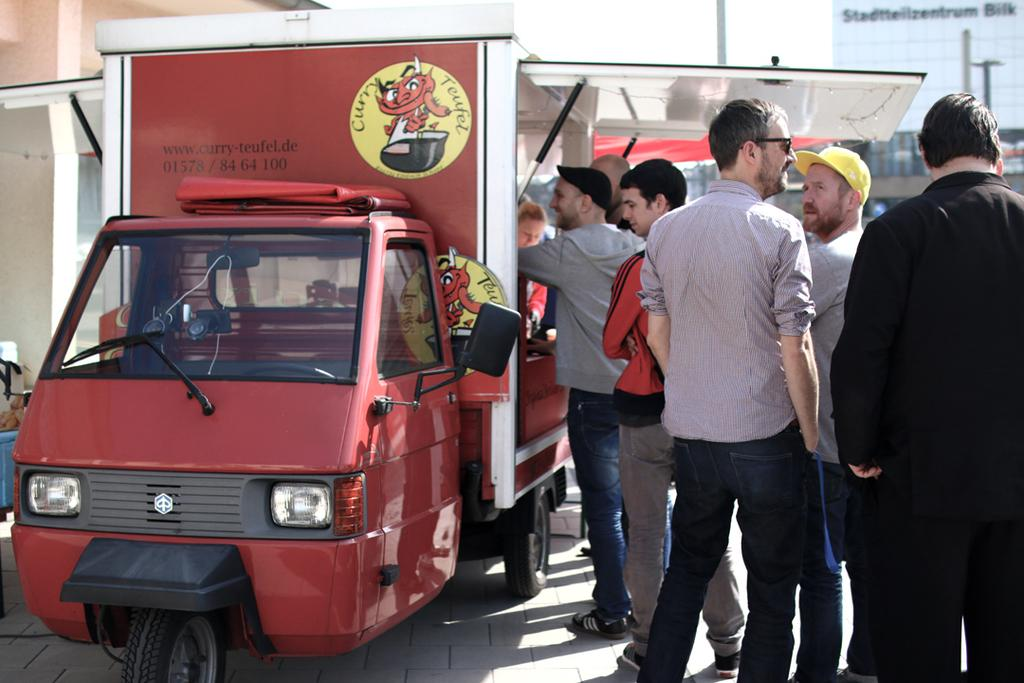What type of vehicle is in the image? There is an auto in the image. What color is the auto? The auto is red in color. What is inside the auto? The auto has food items in it. What can be seen on the right side of the image? There are men standing in a queue on the right side of the image. Can you tell me how many snakes are crawling on the auto in the image? There are no snakes present in the image; the auto has food items inside it. 